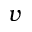Convert formula to latex. <formula><loc_0><loc_0><loc_500><loc_500>v</formula> 